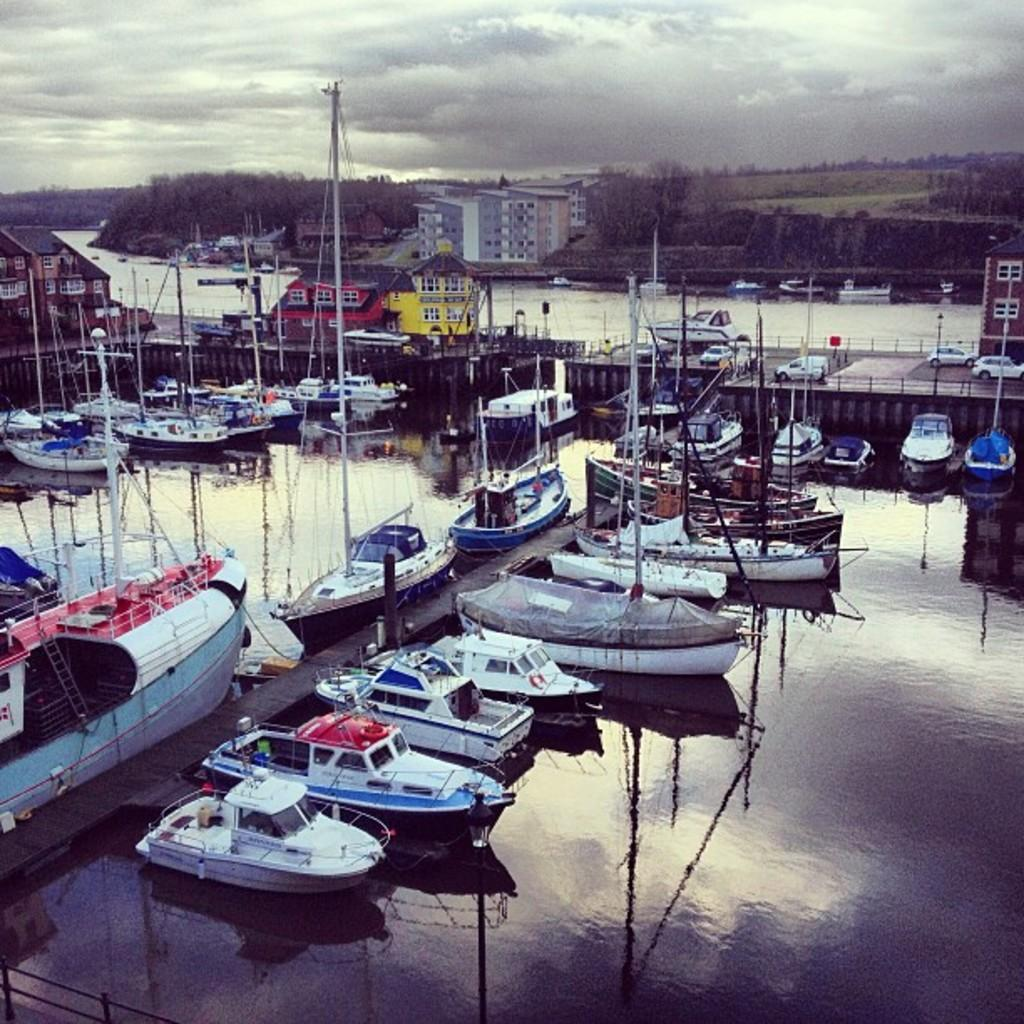What is in the water in the image? There are boats in the water in the image. What can be seen in the background of the image? There are buildings, vehicles, and trees in the background of the image. What is visible in the sky? The sky is visible in the image. Can you hear any songs being sung by the zebra in the image? There is no zebra present in the image, and therefore no singing can be heard. Is there any exchange of currency happening in the image? There is no indication of any currency exchange in the image. 